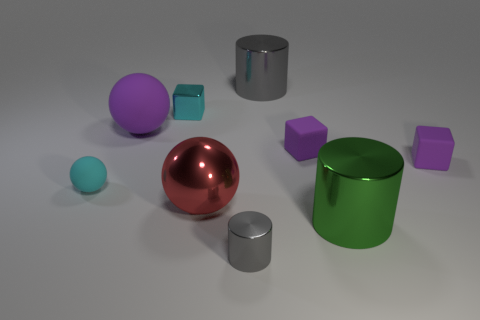Is the small ball the same color as the shiny block?
Make the answer very short. Yes. What shape is the shiny thing that is both in front of the cyan matte thing and to the right of the tiny gray object?
Your response must be concise. Cylinder. Are there any other rubber things that have the same size as the cyan matte object?
Provide a succinct answer. Yes. Do the big shiny ball and the shiny object that is to the left of the big red shiny ball have the same color?
Provide a short and direct response. No. What material is the cyan ball?
Keep it short and to the point. Rubber. There is a big metal cylinder in front of the big rubber ball; what color is it?
Give a very brief answer. Green. What number of tiny rubber blocks have the same color as the large rubber sphere?
Your answer should be very brief. 2. What number of metallic cylinders are behind the tiny gray shiny cylinder and left of the green cylinder?
Keep it short and to the point. 1. There is a green thing that is the same size as the purple sphere; what shape is it?
Offer a terse response. Cylinder. How big is the cyan ball?
Offer a very short reply. Small. 